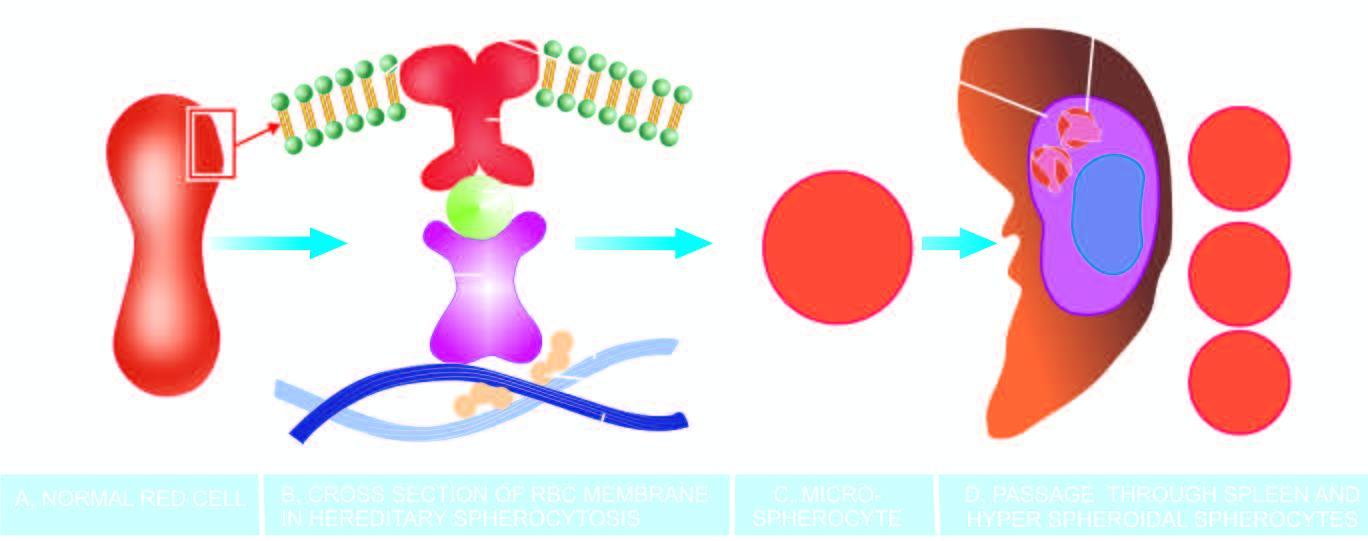does bdominal fat aspirate stained with congo red produce a circulating subpopulation of hyperspheroidal spherocytes while splenic macrophages in large numbers phagocytose defective red cells causing splenomegaly?
Answer the question using a single word or phrase. No 